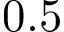<formula> <loc_0><loc_0><loc_500><loc_500>0 . 5</formula> 